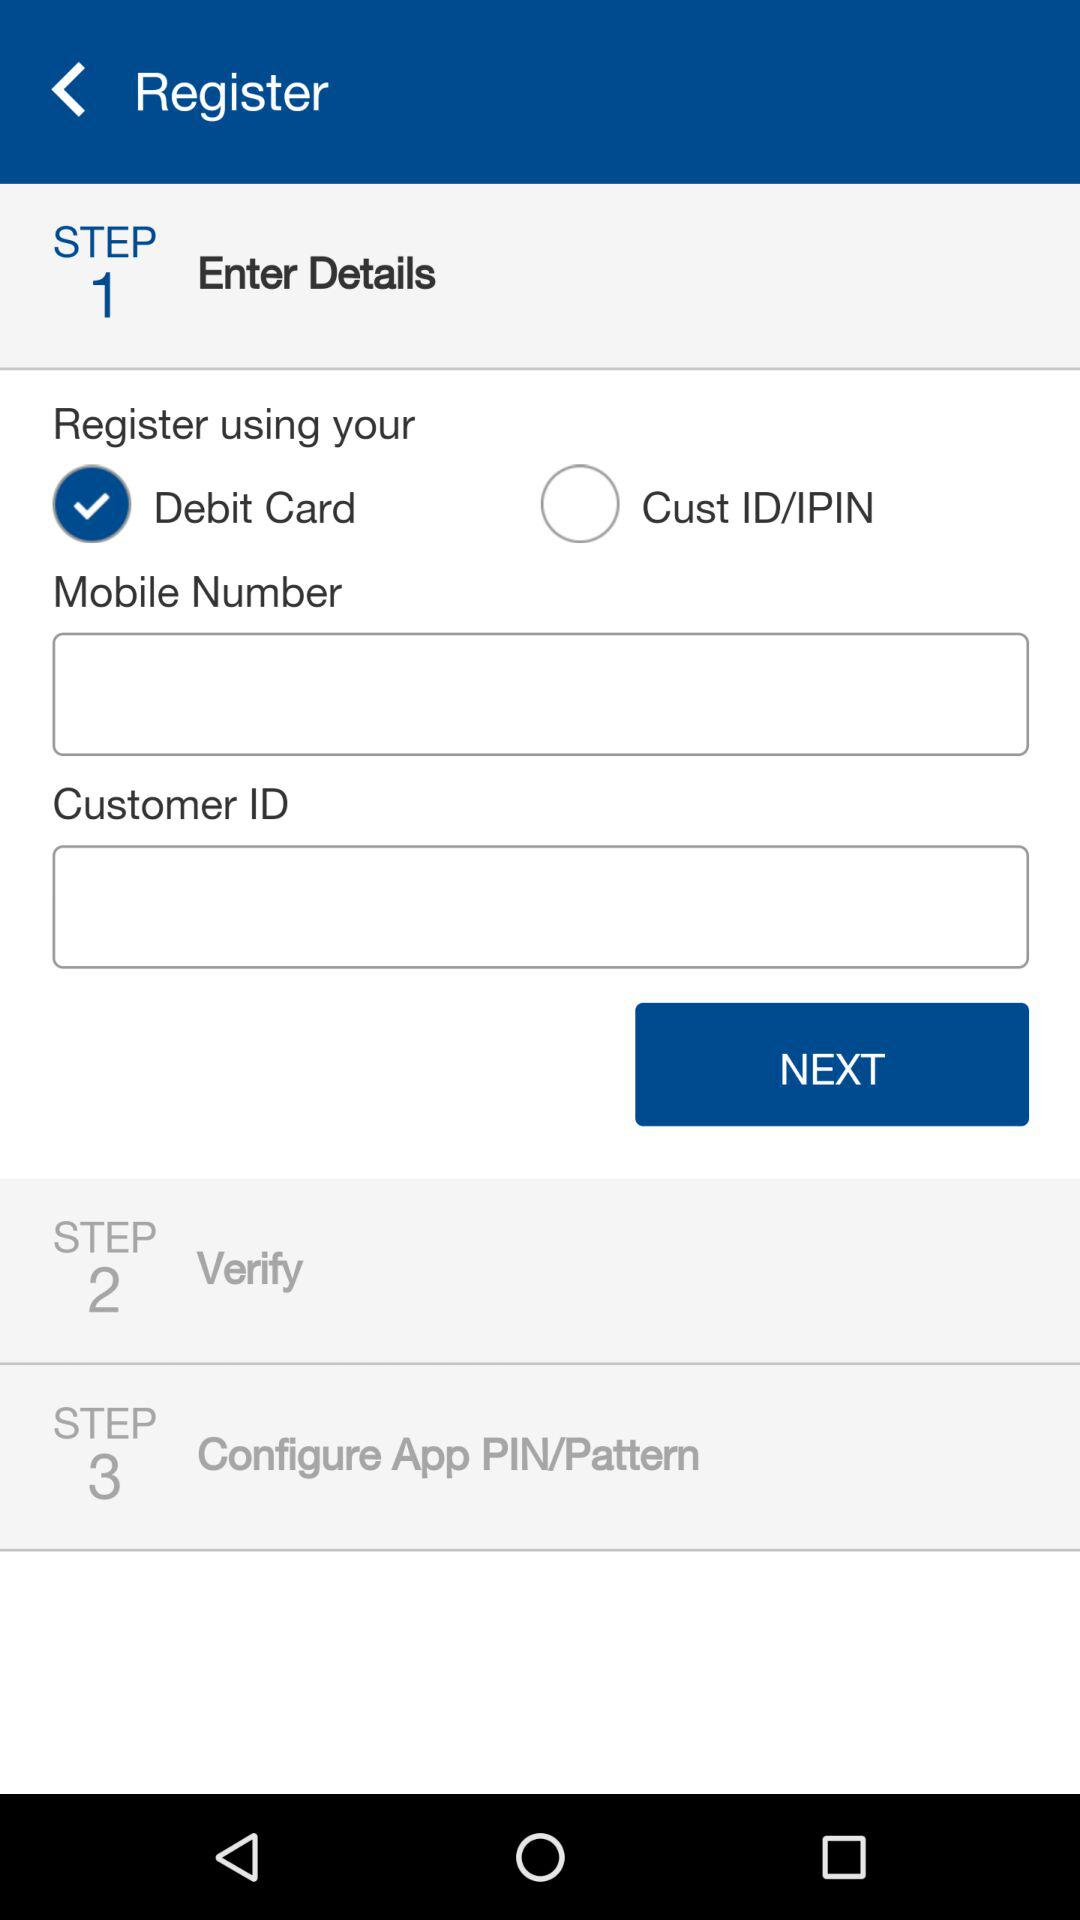How many steps are there in the registration process?
Answer the question using a single word or phrase. 3 